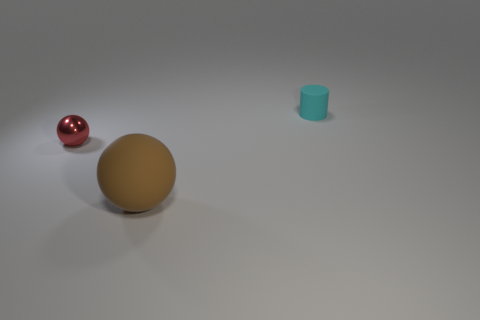Is there a shiny object that has the same color as the large matte sphere?
Keep it short and to the point. No. Is the number of purple rubber cylinders less than the number of tiny shiny balls?
Your answer should be compact. Yes. How many things are big yellow matte spheres or rubber objects right of the big brown ball?
Make the answer very short. 1. Are there any small brown cylinders that have the same material as the tiny red sphere?
Your answer should be compact. No. There is a red object that is the same size as the cyan matte cylinder; what material is it?
Provide a short and direct response. Metal. What is the material of the small thing that is in front of the object that is to the right of the large brown rubber sphere?
Keep it short and to the point. Metal. Does the tiny thing that is behind the tiny metallic ball have the same shape as the large brown rubber thing?
Give a very brief answer. No. There is a cylinder that is the same material as the large thing; what is its color?
Make the answer very short. Cyan. There is a small object to the left of the cylinder; what material is it?
Give a very brief answer. Metal. There is a small cyan rubber object; is it the same shape as the rubber thing that is in front of the metallic object?
Provide a succinct answer. No. 